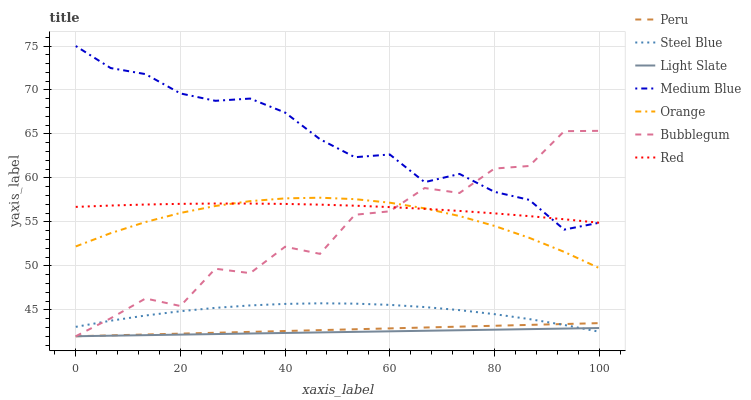Does Light Slate have the minimum area under the curve?
Answer yes or no. Yes. Does Medium Blue have the maximum area under the curve?
Answer yes or no. Yes. Does Steel Blue have the minimum area under the curve?
Answer yes or no. No. Does Steel Blue have the maximum area under the curve?
Answer yes or no. No. Is Light Slate the smoothest?
Answer yes or no. Yes. Is Bubblegum the roughest?
Answer yes or no. Yes. Is Medium Blue the smoothest?
Answer yes or no. No. Is Medium Blue the roughest?
Answer yes or no. No. Does Medium Blue have the lowest value?
Answer yes or no. No. Does Steel Blue have the highest value?
Answer yes or no. No. Is Orange less than Medium Blue?
Answer yes or no. Yes. Is Red greater than Light Slate?
Answer yes or no. Yes. Does Orange intersect Medium Blue?
Answer yes or no. No. 